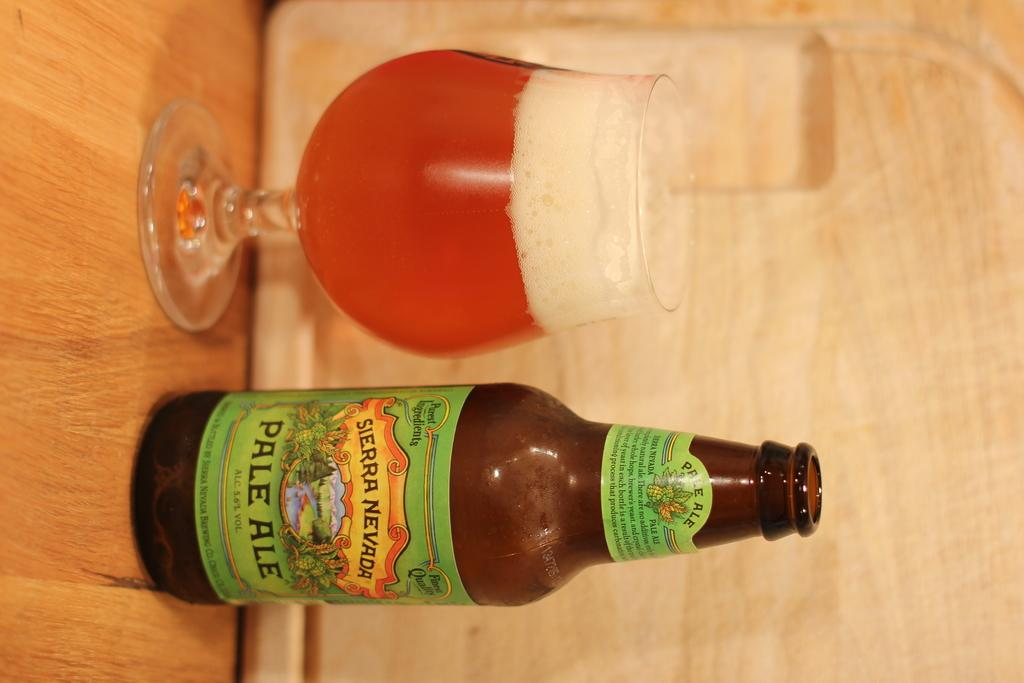<image>
Summarize the visual content of the image. Bottle of Pale Ale along with a glass full sits on a wooden table. 